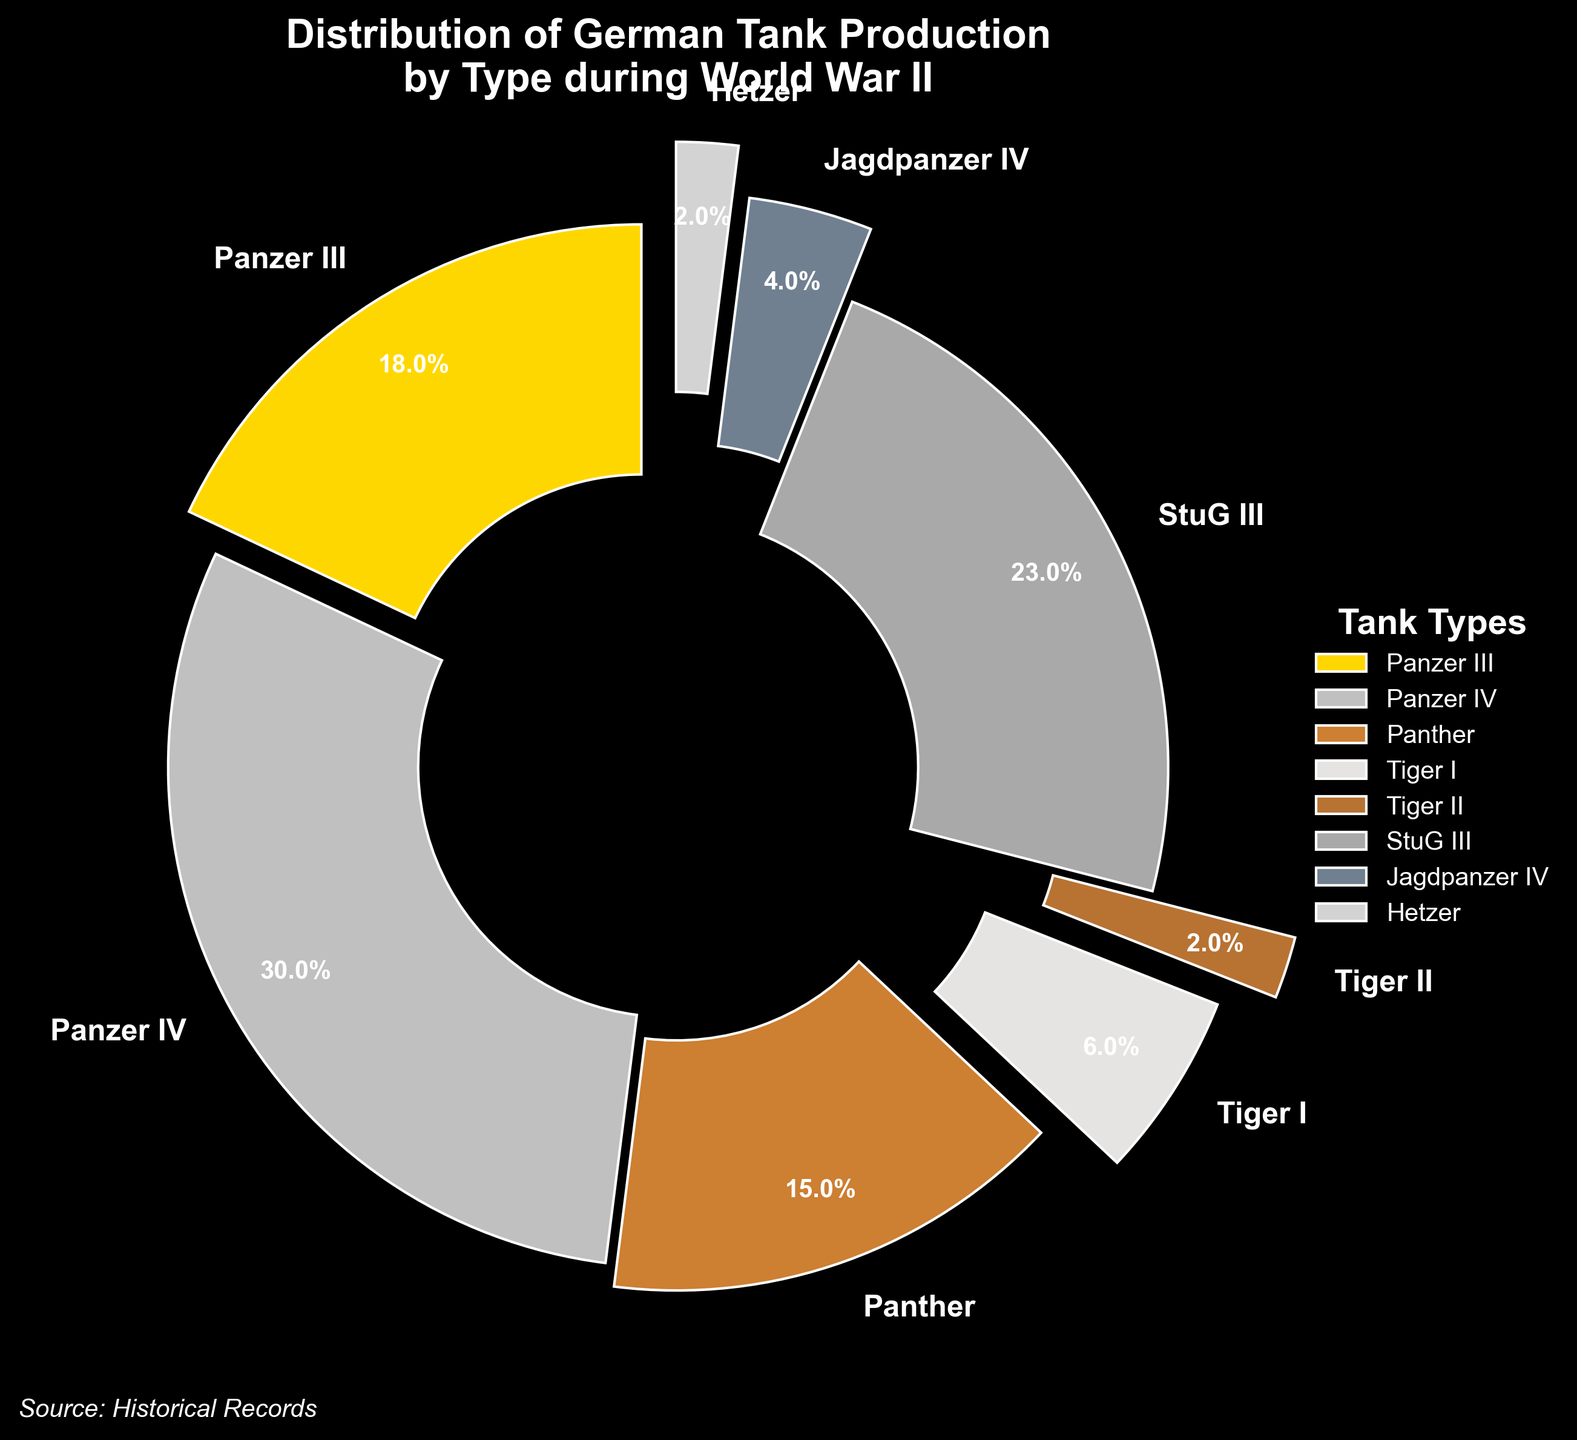Which tank type had the highest production percentage? The Panzer IV tank type had the highest slice in the pie chart with a label indicating 30%.
Answer: Panzer IV What is the combined production percentage of Panzer III and Panther? The pie chart indicates that Panzer III has 18% and Panther has 15%. Adding these two percentages together: 18% + 15% = 33%.
Answer: 33% Which tank type had the lowest production percentage? The Tiger II and Hetzer tank types both had the smallest slices in the pie chart, each labeled 2%.
Answer: Tiger II and Hetzer How does the production percentage of StuG III compare to that of Panthers? StuG III had a production percentage of 23%, while Panthers had 15%. Therefore, StuG III had a higher production percentage than Panthers.
Answer: StuG III had a higher production percentage than Panthers What is the total production percentage of all tank types that had less than 10% production? The tank types with production percentages less than 10% are: Tiger I (6%), Tiger II (2%), Jagdpanzer IV (4%), and Hetzer (2%). Adding these values: 6% + 2% + 4% + 2% = 14%.
Answer: 14% Which tank types are highlighted with the largest explosion effect? The wedges representing Tiger I, Tiger II, and Hetzer are exploded the most, indicating these tank types.
Answer: Tiger I, Tiger II, and Hetzer What is the difference in production percentage between Panzer IV and Jagdpanzer IV? The pie chart indicates that Panzer IV has 30%, and Jagdpanzer IV has 4%. Subtracting these gives 30% - 4% = 26%.
Answer: 26% How does the StuG III's explosion effect compare to the Panther's? StuG III has no explosion effect, while Panthers have a slight explosion as indicated by the visual separation in the pie chart. Therefore, Panther has a noticeable explosion effect compared to StuG III.
Answer: Panther has a noticeable explosion effect compared to StuG III What percentage more production does Panzer IV have compared to Panzer III? The production percentage for Panzer IV is 30%, and for Panzer III, it is 18%. The difference is 30% - 18% = 12%. Therefore, Panzer IV has 12% more production than Panzer III.
Answer: 12% 